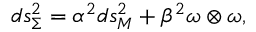<formula> <loc_0><loc_0><loc_500><loc_500>d s _ { \Sigma } ^ { 2 } = \alpha ^ { 2 } { d s _ { M } ^ { 2 } } + \beta ^ { 2 } \omega \otimes \omega ,</formula> 